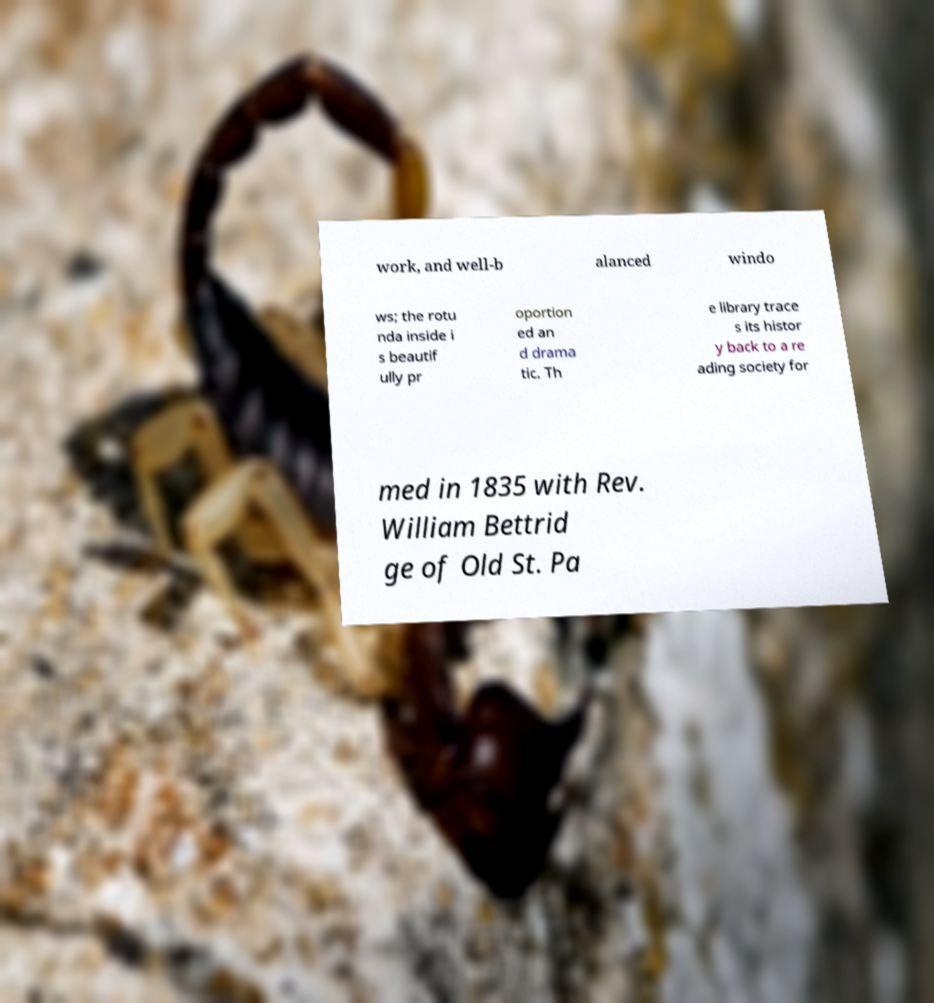Could you extract and type out the text from this image? work, and well-b alanced windo ws; the rotu nda inside i s beautif ully pr oportion ed an d drama tic. Th e library trace s its histor y back to a re ading society for med in 1835 with Rev. William Bettrid ge of Old St. Pa 